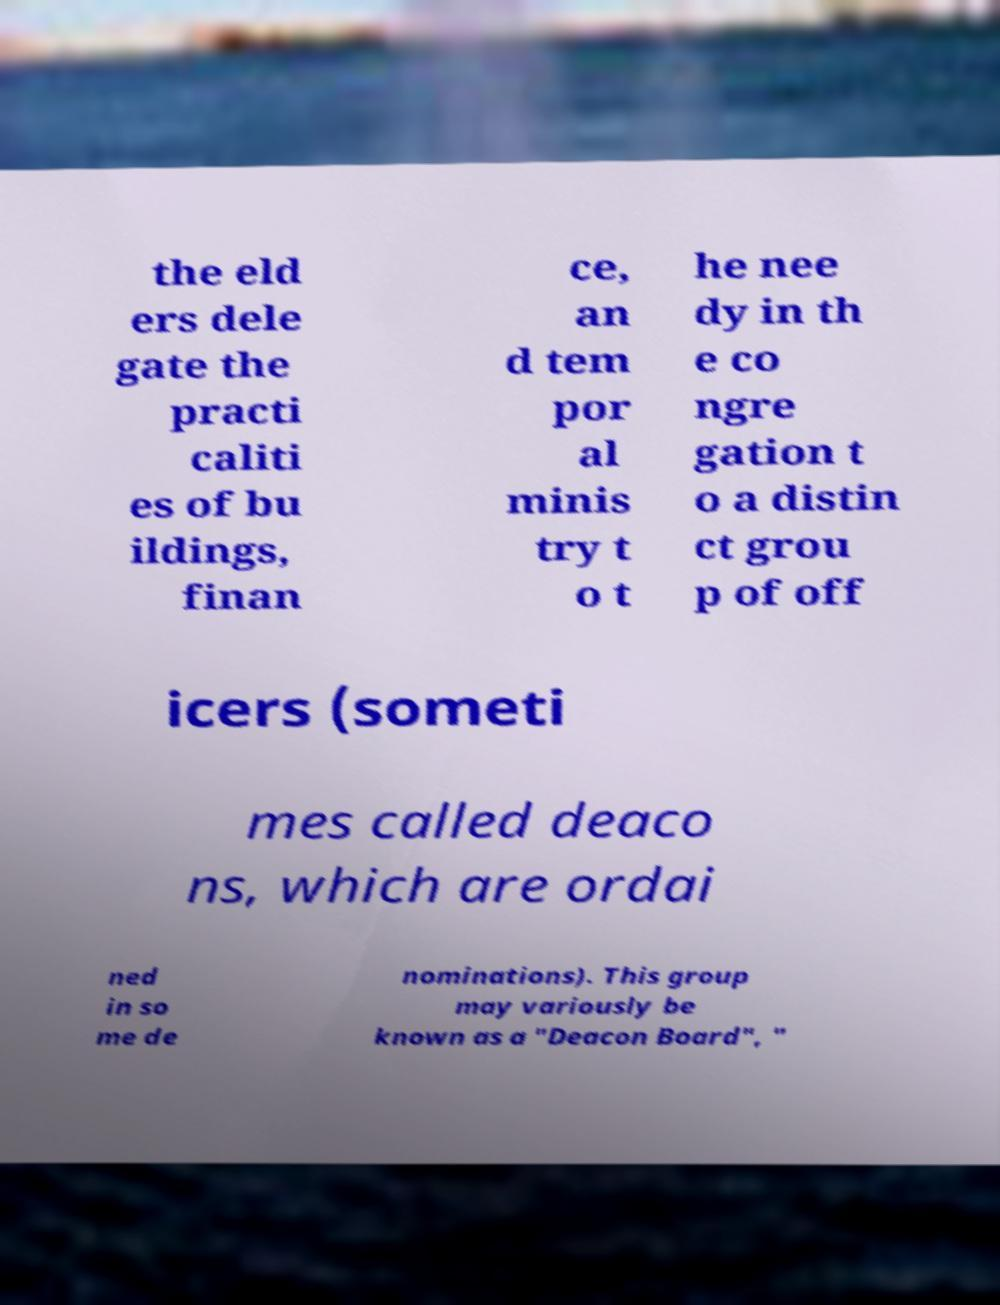For documentation purposes, I need the text within this image transcribed. Could you provide that? the eld ers dele gate the practi caliti es of bu ildings, finan ce, an d tem por al minis try t o t he nee dy in th e co ngre gation t o a distin ct grou p of off icers (someti mes called deaco ns, which are ordai ned in so me de nominations). This group may variously be known as a "Deacon Board", " 